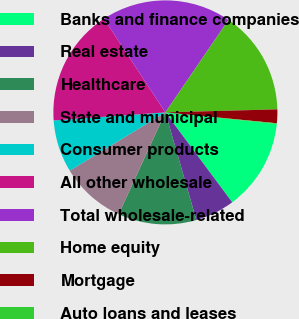Convert chart. <chart><loc_0><loc_0><loc_500><loc_500><pie_chart><fcel>Banks and finance companies<fcel>Real estate<fcel>Healthcare<fcel>State and municipal<fcel>Consumer products<fcel>All other wholesale<fcel>Total wholesale-related<fcel>Home equity<fcel>Mortgage<fcel>Auto loans and leases<nl><fcel>13.17%<fcel>5.71%<fcel>11.31%<fcel>9.44%<fcel>7.57%<fcel>16.9%<fcel>18.77%<fcel>15.04%<fcel>1.98%<fcel>0.11%<nl></chart> 